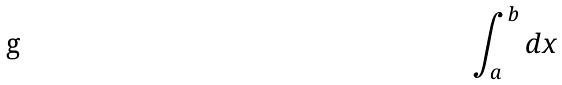Convert formula to latex. <formula><loc_0><loc_0><loc_500><loc_500>\int _ { a } ^ { b } d x</formula> 